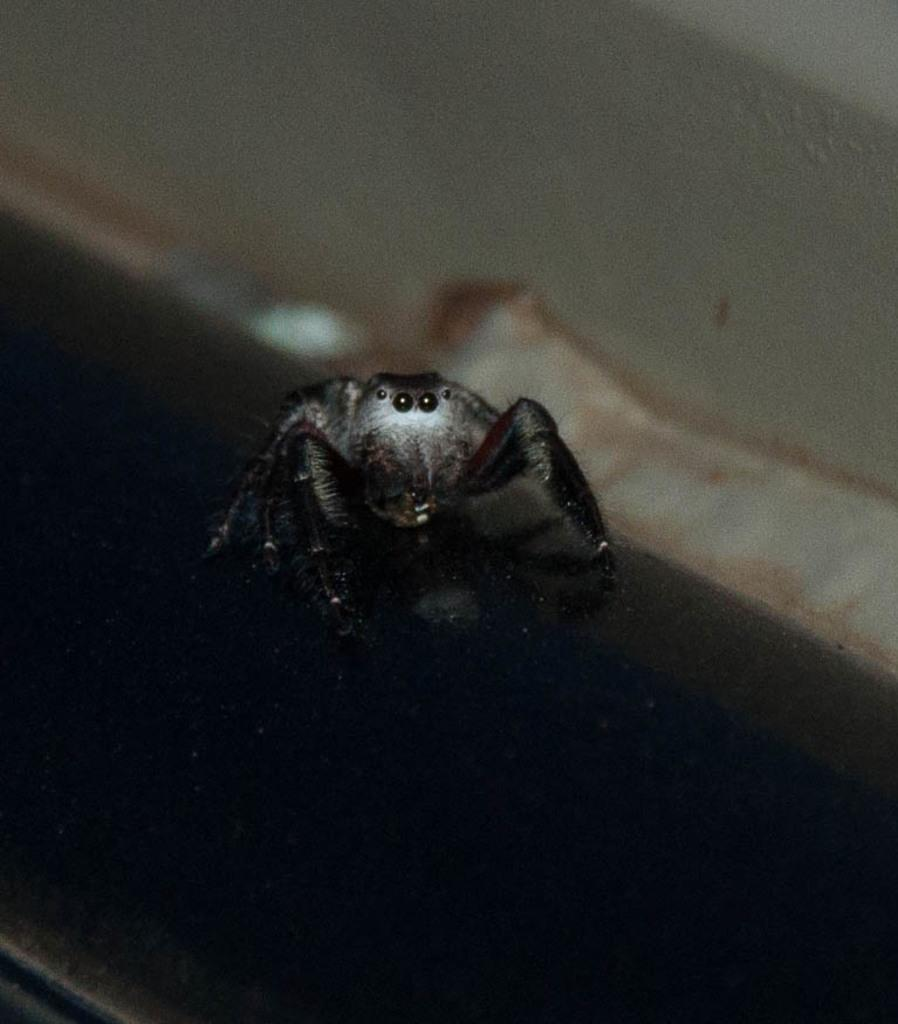What type of creature is present in the image? There is an insect in the image. Where is the insect situated in relation to the surface? The insect is on the surface. How is the insect positioned within the image? The insect is located in the center of the image. How many toes can be seen on the insect in the image? Insects do not have toes, so this detail cannot be observed in the image. What type of bird is present in the image? There are no birds, including chickens or turkeys, present in the image; it features an insect. 